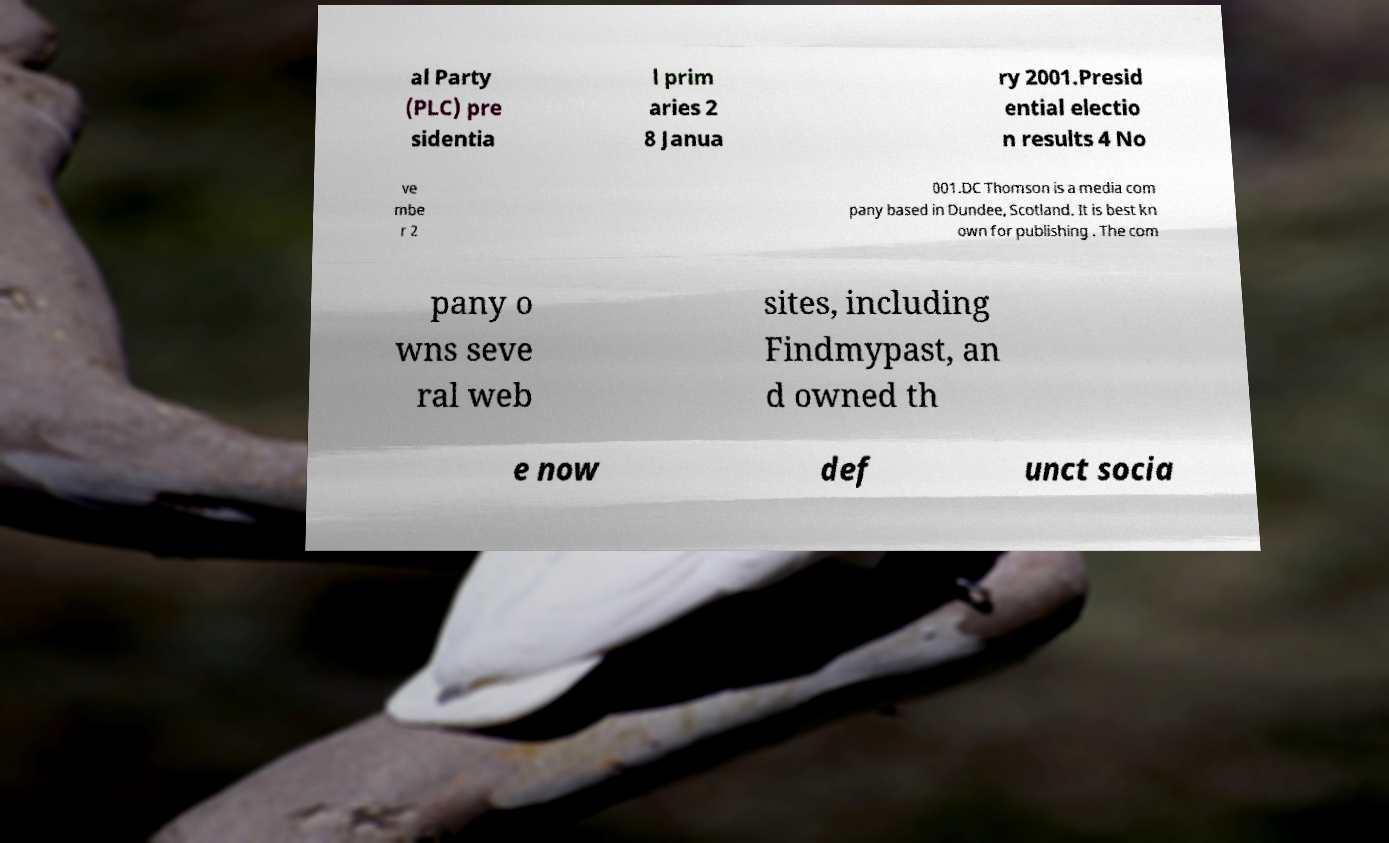There's text embedded in this image that I need extracted. Can you transcribe it verbatim? al Party (PLC) pre sidentia l prim aries 2 8 Janua ry 2001.Presid ential electio n results 4 No ve mbe r 2 001.DC Thomson is a media com pany based in Dundee, Scotland. It is best kn own for publishing . The com pany o wns seve ral web sites, including Findmypast, an d owned th e now def unct socia 